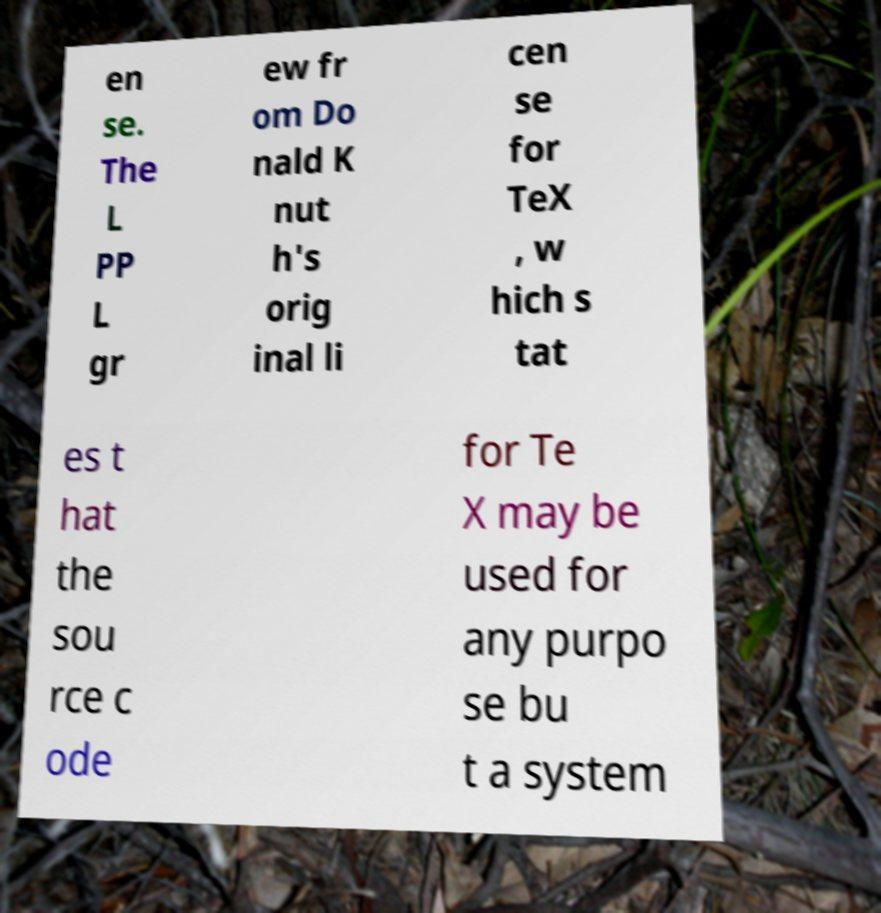Could you extract and type out the text from this image? en se. The L PP L gr ew fr om Do nald K nut h's orig inal li cen se for TeX , w hich s tat es t hat the sou rce c ode for Te X may be used for any purpo se bu t a system 